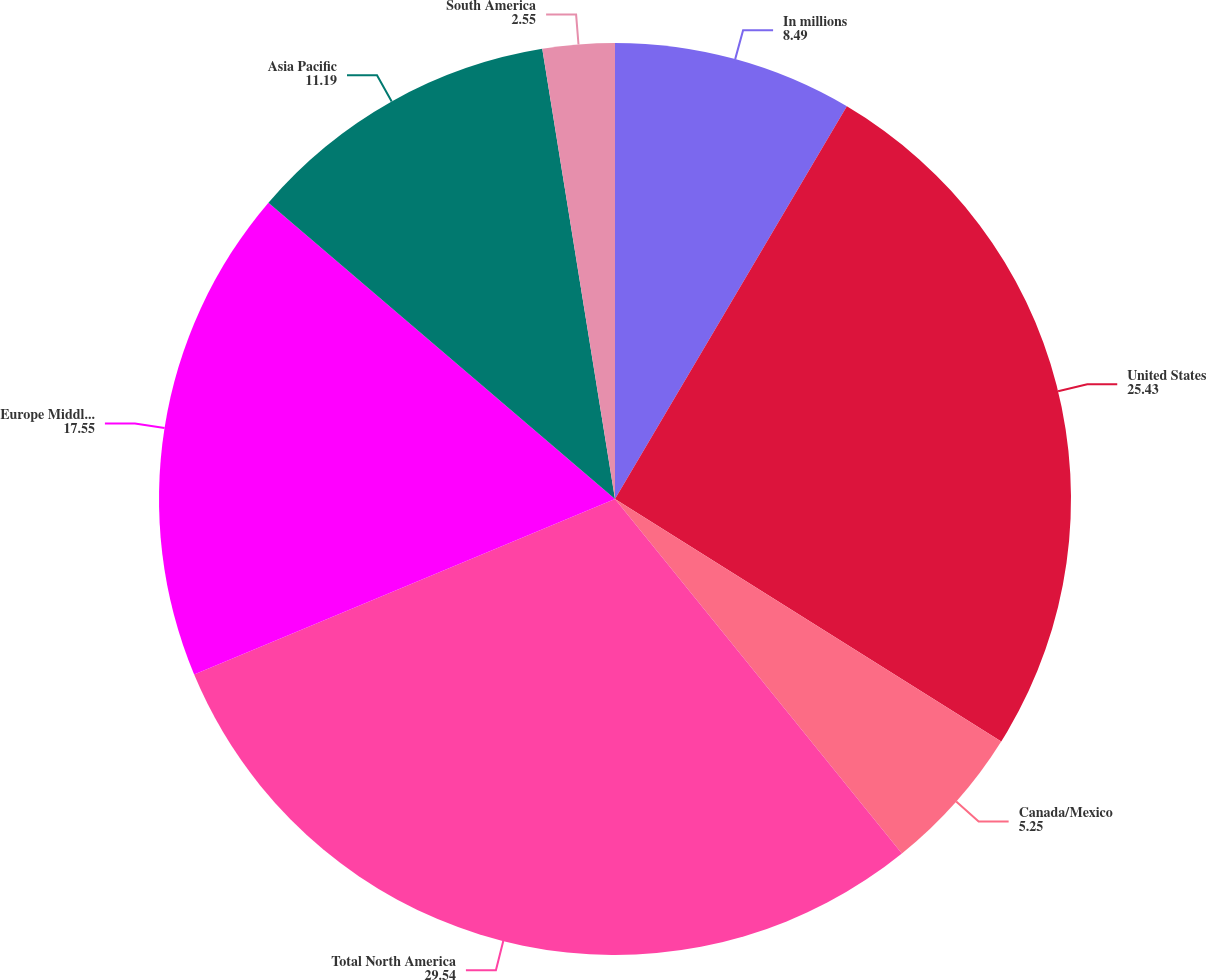Convert chart. <chart><loc_0><loc_0><loc_500><loc_500><pie_chart><fcel>In millions<fcel>United States<fcel>Canada/Mexico<fcel>Total North America<fcel>Europe Middle East and Africa<fcel>Asia Pacific<fcel>South America<nl><fcel>8.49%<fcel>25.43%<fcel>5.25%<fcel>29.54%<fcel>17.55%<fcel>11.19%<fcel>2.55%<nl></chart> 